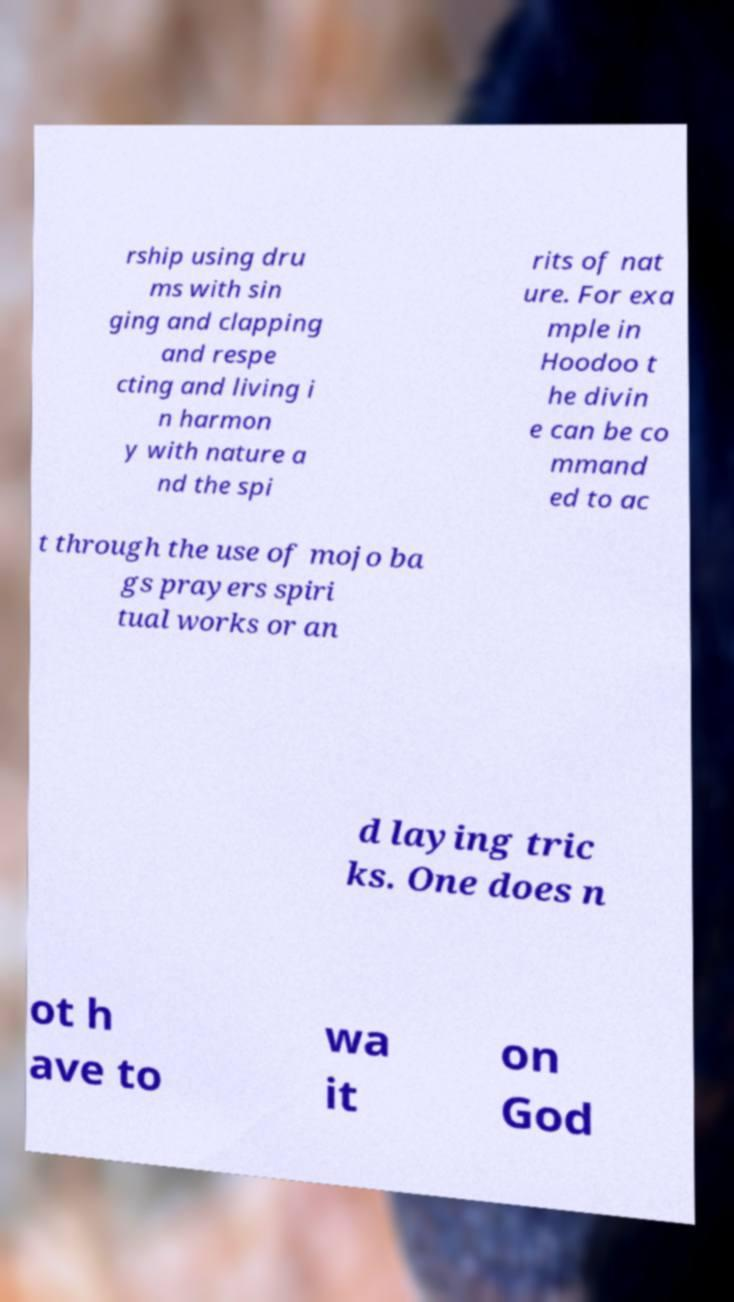What messages or text are displayed in this image? I need them in a readable, typed format. rship using dru ms with sin ging and clapping and respe cting and living i n harmon y with nature a nd the spi rits of nat ure. For exa mple in Hoodoo t he divin e can be co mmand ed to ac t through the use of mojo ba gs prayers spiri tual works or an d laying tric ks. One does n ot h ave to wa it on God 